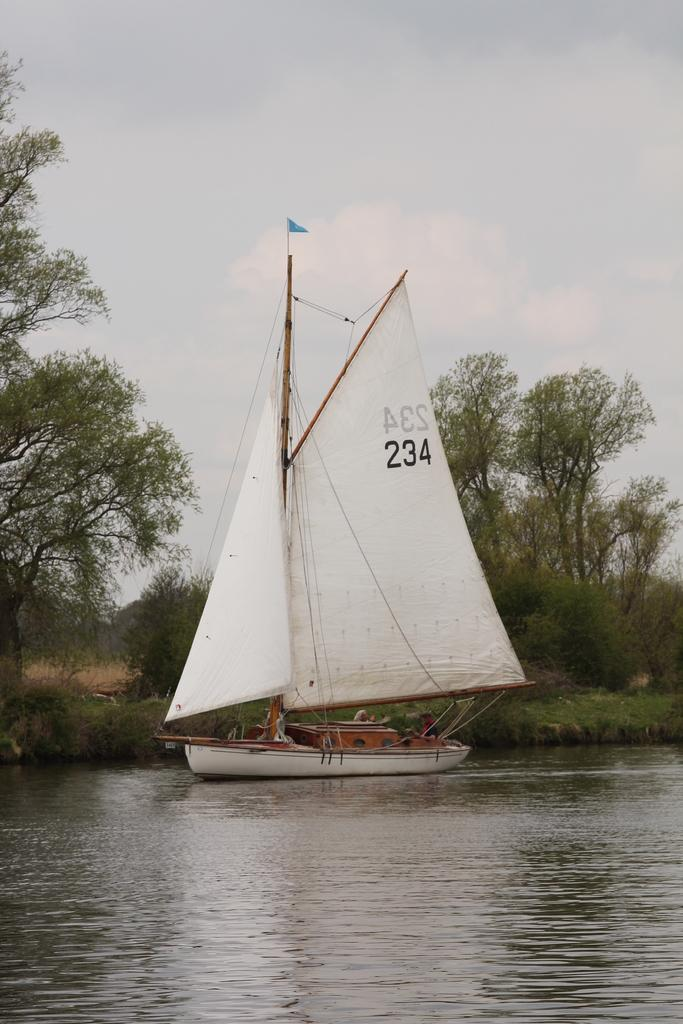What is the main subject of the image? The main subject of the image is a ship. Where is the ship located in the image? The ship is on a river in the image. What can be seen in the background of the image? There are trees and the sky visible in the background of the image. What type of tray is being used to carry the ship in the image? There is no tray present in the image, and the ship is not being carried. 